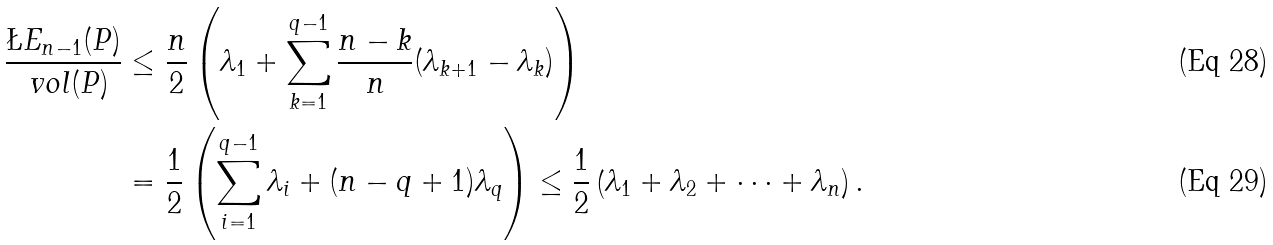Convert formula to latex. <formula><loc_0><loc_0><loc_500><loc_500>\frac { \L E _ { n - 1 } ( P ) } { \ v o l ( P ) } & \leq \frac { n } { 2 } \left ( \lambda _ { 1 } + \sum _ { k = 1 } ^ { q - 1 } \frac { n - k } { n } ( \lambda _ { k + 1 } - \lambda _ { k } ) \right ) \\ & = \frac { 1 } { 2 } \left ( \sum _ { i = 1 } ^ { q - 1 } \lambda _ { i } + ( n - q + 1 ) \lambda _ { q } \right ) \leq \frac { 1 } { 2 } \left ( \lambda _ { 1 } + \lambda _ { 2 } + \cdots + \lambda _ { n } \right ) .</formula> 